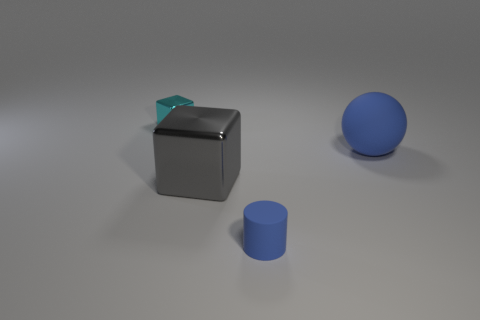Can you describe the differences between the shapes in the image? Certainly. There are three distinct shapes present in the image: a cylinder, a sphere, and a cube. The cylinder has a circular base with straight, parallel sides. The sphere is a perfectly round, three-dimensional shape with every point on its surface equidistant from its center. The cube is a six-sided figure with square faces of equal size and all angles at 90 degrees, giving it a uniform look from all corners. 